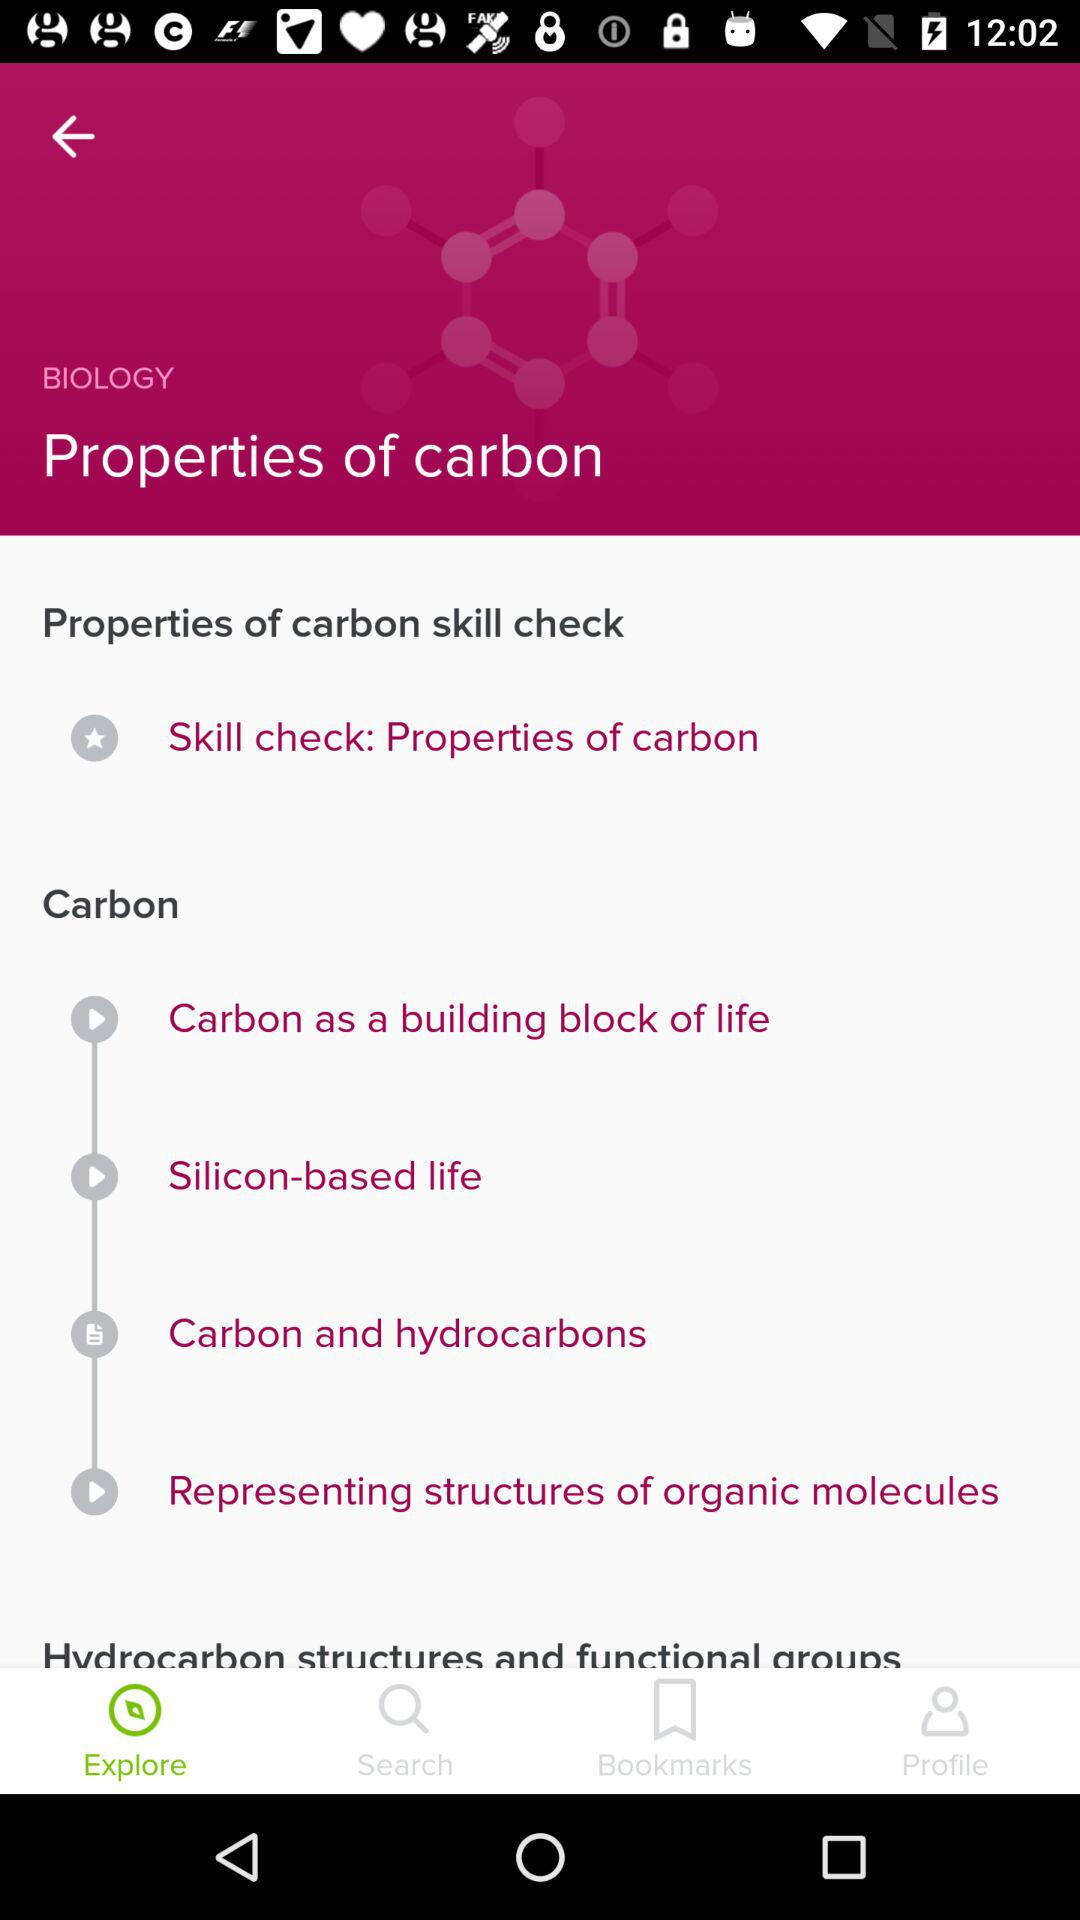What is the selected option? The selected option is "Explore". 